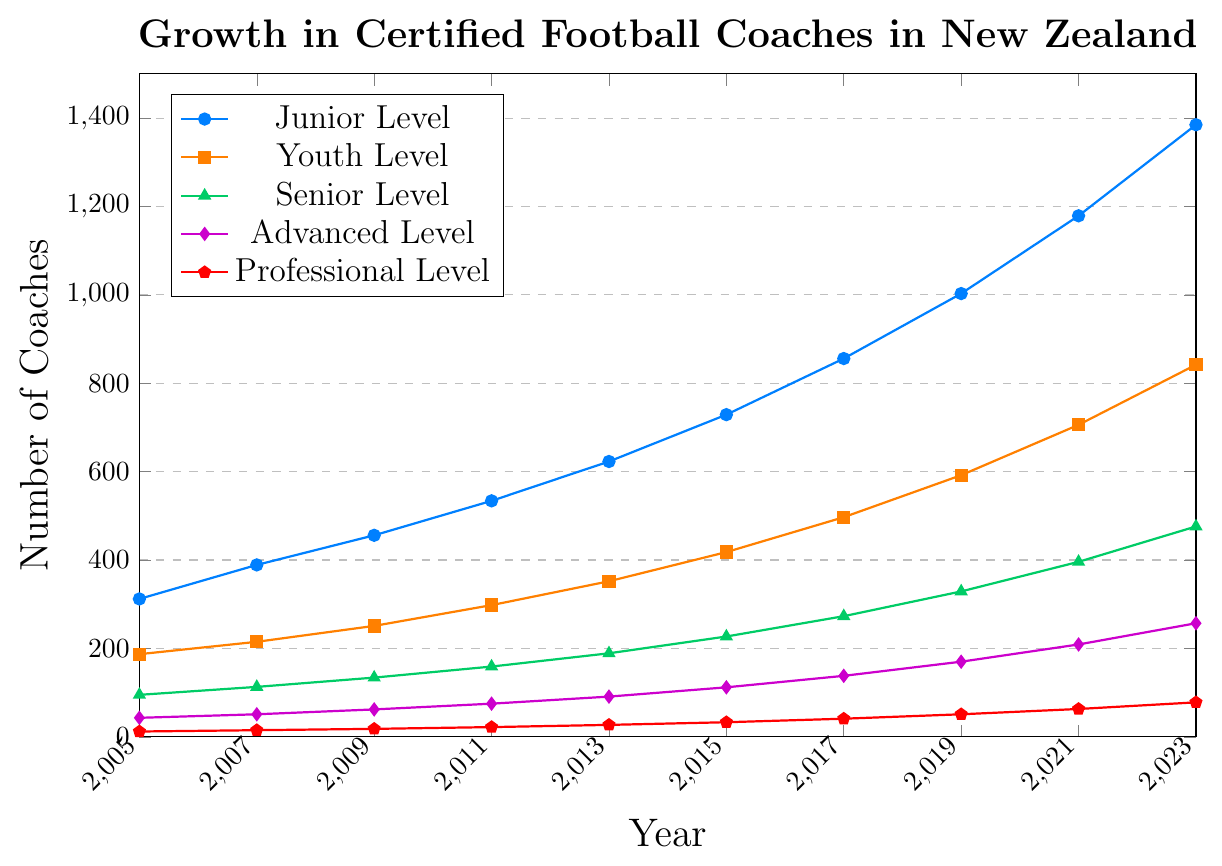What is the total number of certified Junior Level coaches by 2023? From the graph, the number of certified Junior Level coaches in 2023 is 1385. Simply read the data point from the line representing Junior Level coaches.
Answer: 1385 Which coaching level saw the least growth from 2005 to 2023? Compare the starting and ending values for each coaching level from 2005 to 2023. The Professional Level started at 12 in 2005 and increased to 78 in 2023, the least growth compared to other levels.
Answer: Professional Level In which year did the number of Youth Level coaches first exceed 300? Look at the Youth Level line and identify the year when it passes the 300 mark. By checking the data points, in 2011, the number of Youth Level coaches first exceeded 300, reaching 352.
Answer: 2011 For which coaching levels did the number of certified coaches exceed 500 by 2023? Check the data points for each coaching level in 2023. Junior, Youth, and Senior Levels have more than 500 (values are 1385, 842, and 476 respectively), while Advanced and Professional Levels do not.
Answer: Junior Level, Youth Level What is the combined number of Senior and Advanced Level coaches in 2015? Sum the number of Senior Level coaches (227) and Advanced Level coaches (112) in 2015. This gives 227 + 112 = 339.
Answer: 339 Which coaching level has the steepest growth rate between 2005 and 2023? The steepest growth rate can be identified by the steepest slope on the graph. The Junior Level has the most significant increase from 312 in 2005 to 1385 in 2023, indicating the steepest growth rate.
Answer: Junior Level How many more Junior Level coaches were there in 2023 compared to 2011? Subtract the number of Junior Level coaches in 2011 from the number in 2023. 1385 (2023) - 534 (2011) = 851.
Answer: 851 What's the percentage increase in the number of certified Professional Level coaches from 2005 to 2023? Calculate the percentage increase with the formula: ((new - old) / old) * 100. For Professional Level: ((78 - 12) / 12) * 100 = 550%.
Answer: 550% How many total certified football coaches were there in New Zealand in 2023? Sum the number of certified coaches for each level in 2023: 1385 + 842 + 476 + 257 + 78 = 3038.
Answer: 3038 In what year did the number of Advanced Level coaches reach 100? Identify the year when the Advanced Level line first surpasses 100. By checking the data points, this occurred in 2015, with 112 Advanced Level coaches.
Answer: 2015 